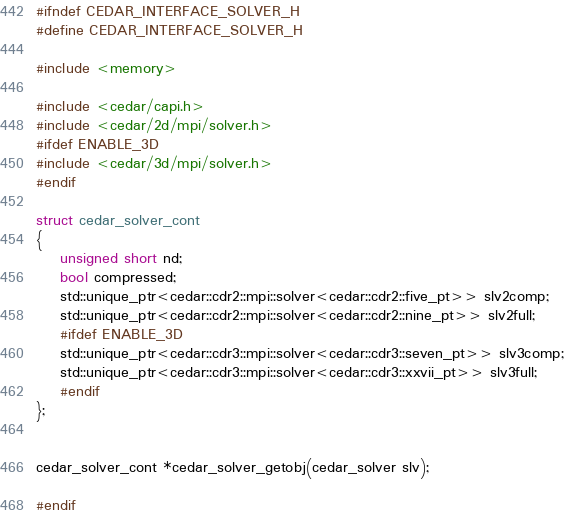Convert code to text. <code><loc_0><loc_0><loc_500><loc_500><_C_>#ifndef CEDAR_INTERFACE_SOLVER_H
#define CEDAR_INTERFACE_SOLVER_H

#include <memory>

#include <cedar/capi.h>
#include <cedar/2d/mpi/solver.h>
#ifdef ENABLE_3D
#include <cedar/3d/mpi/solver.h>
#endif

struct cedar_solver_cont
{
	unsigned short nd;
	bool compressed;
	std::unique_ptr<cedar::cdr2::mpi::solver<cedar::cdr2::five_pt>> slv2comp;
	std::unique_ptr<cedar::cdr2::mpi::solver<cedar::cdr2::nine_pt>> slv2full;
	#ifdef ENABLE_3D
	std::unique_ptr<cedar::cdr3::mpi::solver<cedar::cdr3::seven_pt>> slv3comp;
	std::unique_ptr<cedar::cdr3::mpi::solver<cedar::cdr3::xxvii_pt>> slv3full;
	#endif
};


cedar_solver_cont *cedar_solver_getobj(cedar_solver slv);

#endif
</code> 